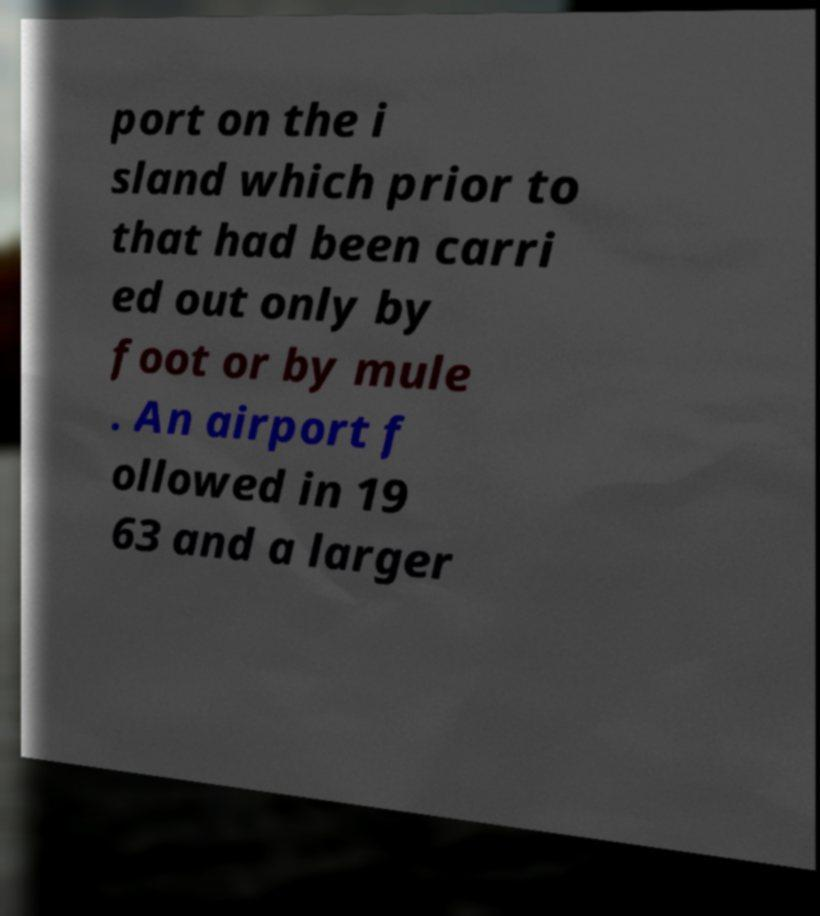Please identify and transcribe the text found in this image. port on the i sland which prior to that had been carri ed out only by foot or by mule . An airport f ollowed in 19 63 and a larger 